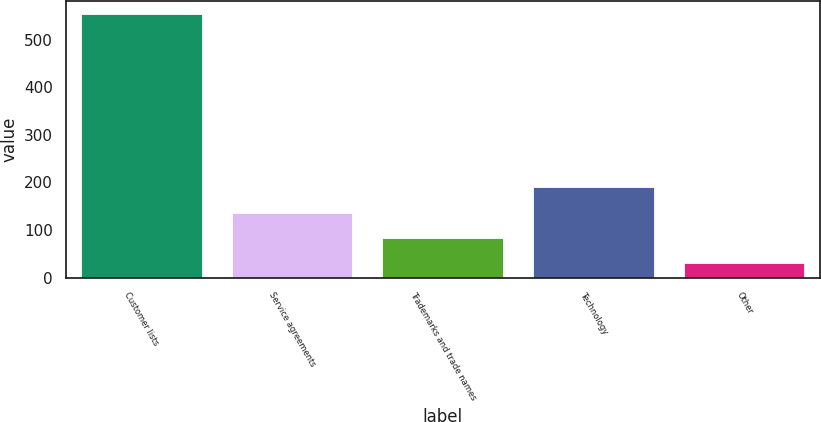Convert chart. <chart><loc_0><loc_0><loc_500><loc_500><bar_chart><fcel>Customer lists<fcel>Service agreements<fcel>Trademarks and trade names<fcel>Technology<fcel>Other<nl><fcel>554<fcel>135.6<fcel>83.3<fcel>190<fcel>31<nl></chart> 